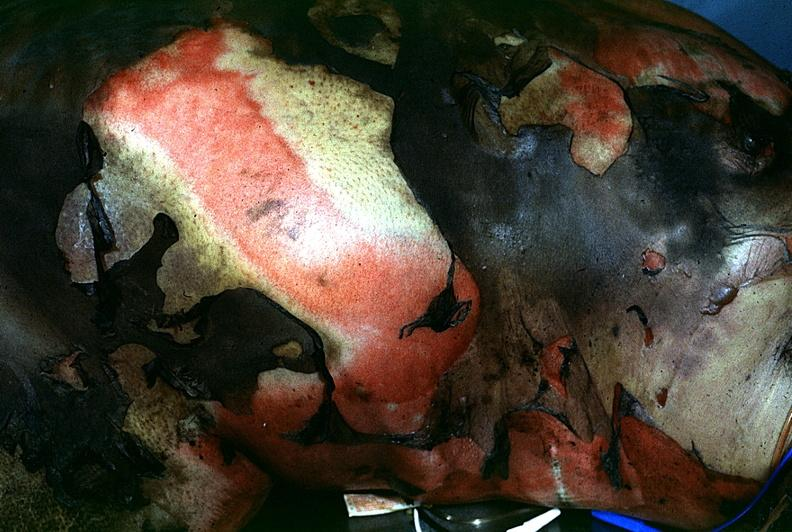does this image show thermal burn?
Answer the question using a single word or phrase. Yes 